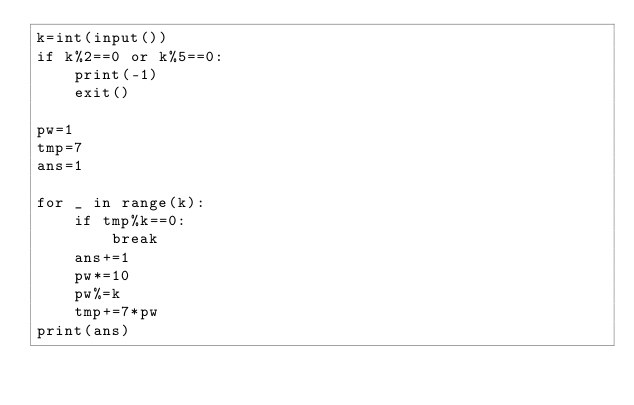<code> <loc_0><loc_0><loc_500><loc_500><_Python_>k=int(input())
if k%2==0 or k%5==0:
    print(-1)
    exit()

pw=1
tmp=7
ans=1

for _ in range(k):
    if tmp%k==0: 
        break
    ans+=1
    pw*=10
    pw%=k
    tmp+=7*pw
print(ans)
</code> 